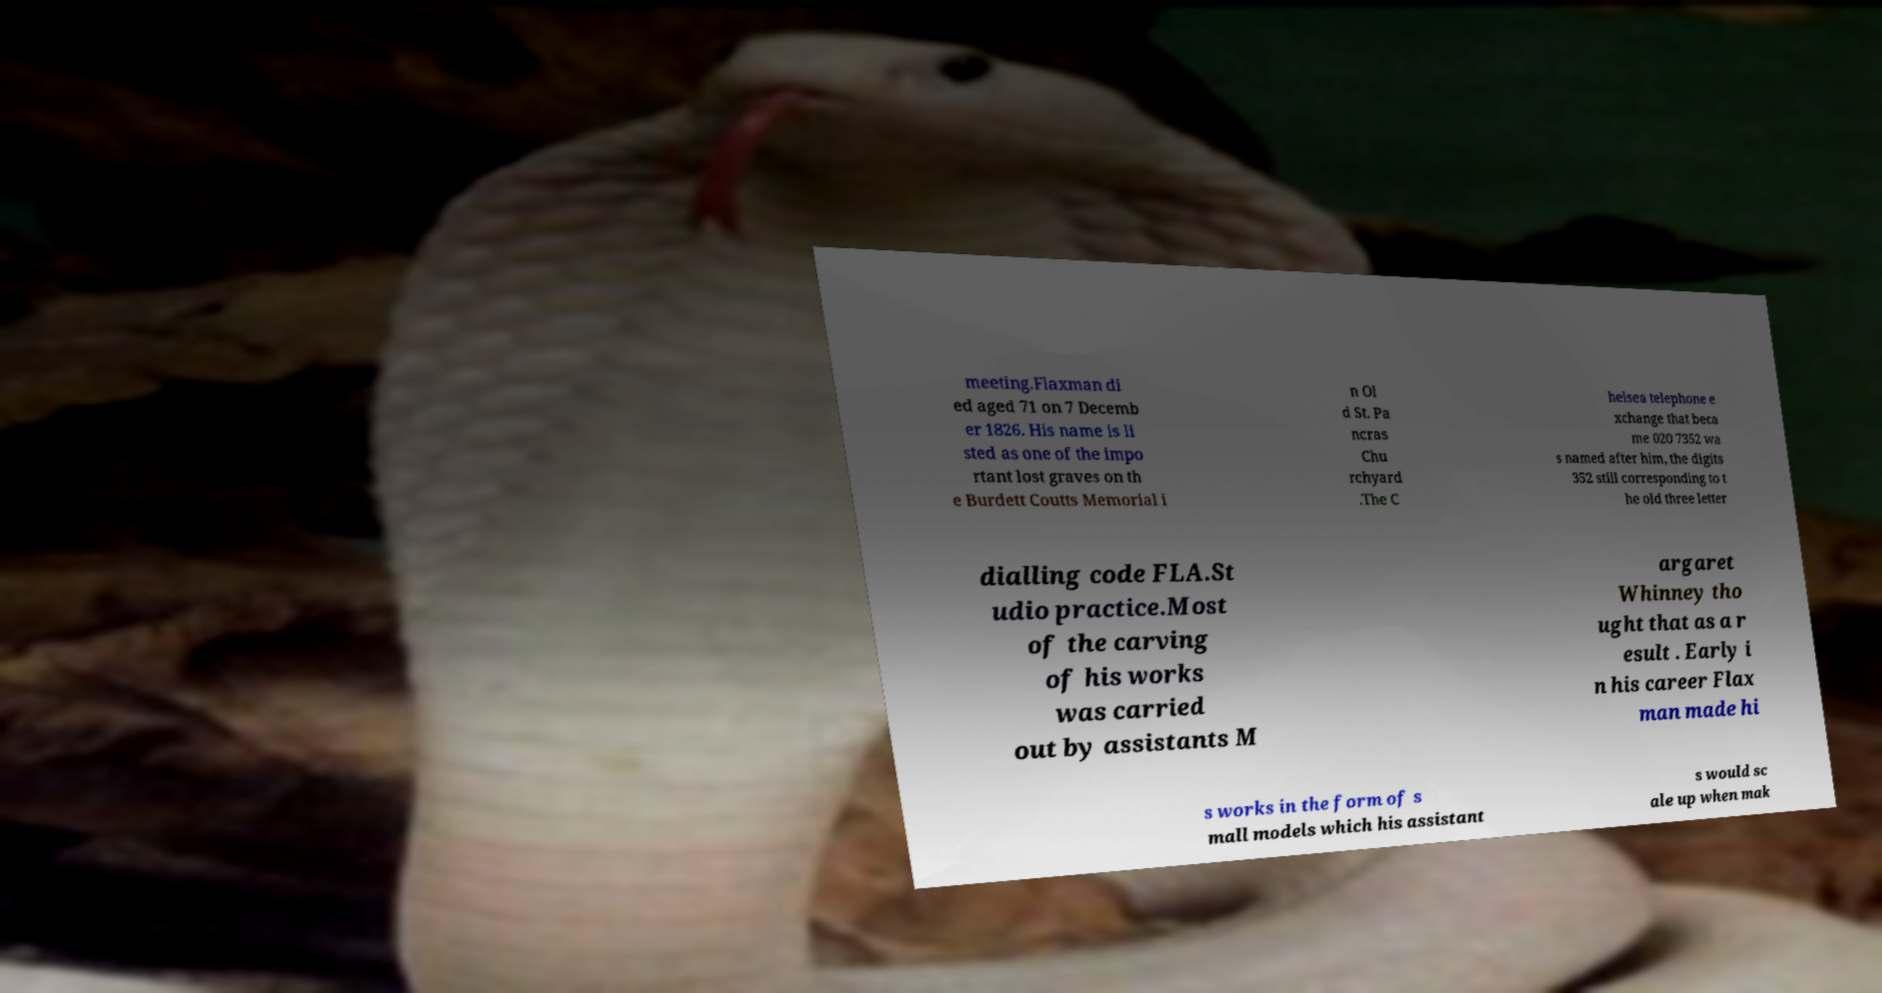Please read and relay the text visible in this image. What does it say? meeting.Flaxman di ed aged 71 on 7 Decemb er 1826. His name is li sted as one of the impo rtant lost graves on th e Burdett Coutts Memorial i n Ol d St. Pa ncras Chu rchyard .The C helsea telephone e xchange that beca me 020 7352 wa s named after him, the digits 352 still corresponding to t he old three letter dialling code FLA.St udio practice.Most of the carving of his works was carried out by assistants M argaret Whinney tho ught that as a r esult . Early i n his career Flax man made hi s works in the form of s mall models which his assistant s would sc ale up when mak 